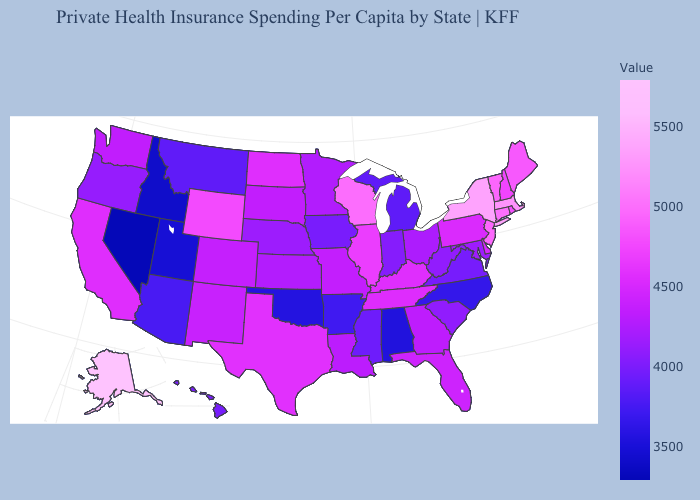Among the states that border Vermont , which have the highest value?
Concise answer only. New York. Does Delaware have a lower value than Alaska?
Concise answer only. Yes. Which states have the highest value in the USA?
Answer briefly. Alaska. Does Georgia have a lower value than New Hampshire?
Concise answer only. Yes. Among the states that border Idaho , does Nevada have the lowest value?
Concise answer only. Yes. Does Georgia have the lowest value in the South?
Answer briefly. No. Does Massachusetts have the highest value in the Northeast?
Write a very short answer. No. Does Texas have the highest value in the South?
Write a very short answer. Yes. 